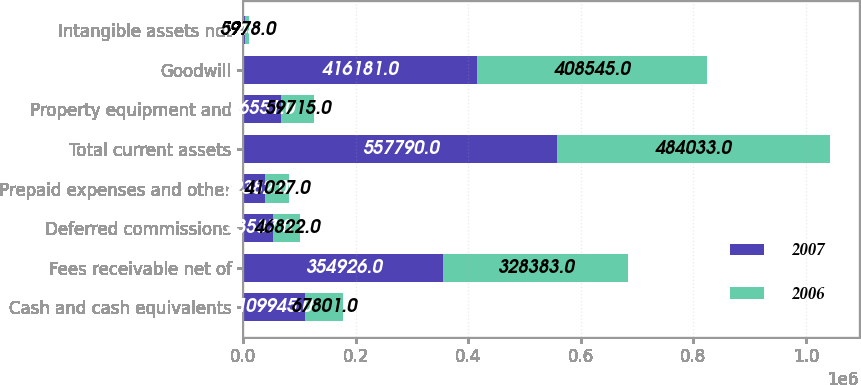Convert chart. <chart><loc_0><loc_0><loc_500><loc_500><stacked_bar_chart><ecel><fcel>Cash and cash equivalents<fcel>Fees receivable net of<fcel>Deferred commissions<fcel>Prepaid expenses and other<fcel>Total current assets<fcel>Property equipment and<fcel>Goodwill<fcel>Intangible assets net<nl><fcel>2007<fcel>109945<fcel>354926<fcel>53537<fcel>39382<fcel>557790<fcel>66551<fcel>416181<fcel>3645<nl><fcel>2006<fcel>67801<fcel>328383<fcel>46822<fcel>41027<fcel>484033<fcel>59715<fcel>408545<fcel>5978<nl></chart> 